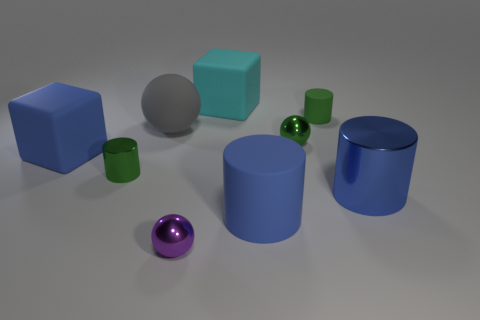What is the material of the big sphere?
Your response must be concise. Rubber. There is a blue rubber object that is on the left side of the large matte cube behind the big blue matte object behind the blue shiny cylinder; how big is it?
Your response must be concise. Large. There is another large cylinder that is the same color as the large rubber cylinder; what is its material?
Your answer should be very brief. Metal. What number of shiny objects are blue objects or big red spheres?
Provide a succinct answer. 1. What is the size of the blue metal cylinder?
Your answer should be very brief. Large. How many objects are either gray matte things or big blue things to the right of the cyan rubber thing?
Offer a terse response. 3. What number of other things are there of the same color as the small shiny cylinder?
Ensure brevity in your answer.  2. There is a green matte cylinder; does it have the same size as the block that is in front of the large cyan matte thing?
Your answer should be very brief. No. Does the cube in front of the gray matte sphere have the same size as the large shiny thing?
Keep it short and to the point. Yes. What number of other things are made of the same material as the big cyan object?
Provide a succinct answer. 4. 